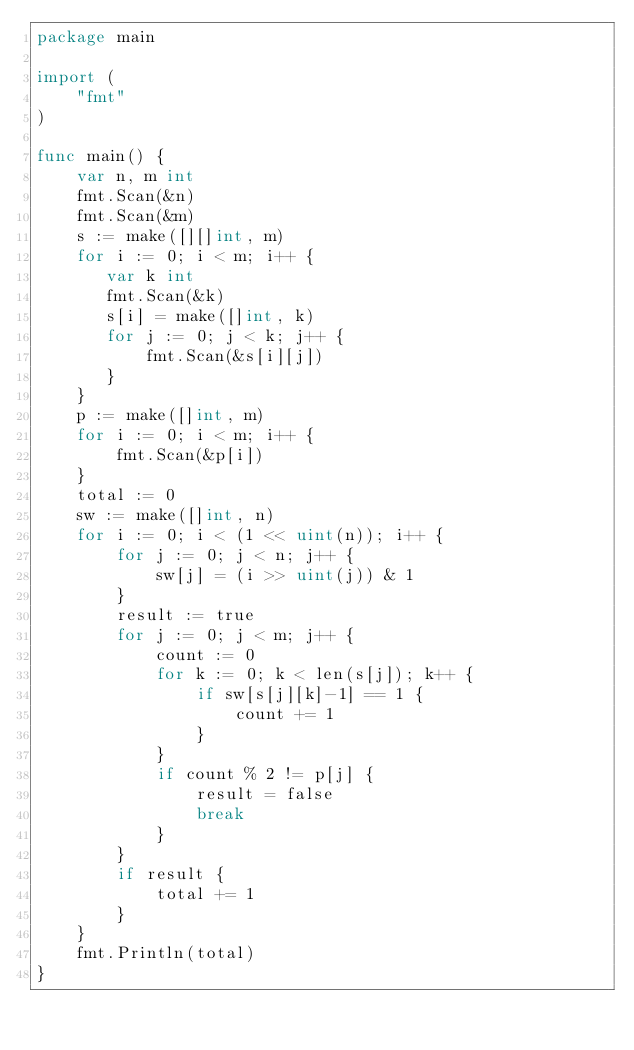Convert code to text. <code><loc_0><loc_0><loc_500><loc_500><_Go_>package main

import (
    "fmt"
)

func main() {
    var n, m int
    fmt.Scan(&n)
    fmt.Scan(&m)
    s := make([][]int, m)
    for i := 0; i < m; i++ {
       var k int
       fmt.Scan(&k)
       s[i] = make([]int, k)
       for j := 0; j < k; j++ {
           fmt.Scan(&s[i][j])
       }
    }
    p := make([]int, m)
    for i := 0; i < m; i++ {
        fmt.Scan(&p[i])
    }
    total := 0
    sw := make([]int, n)
    for i := 0; i < (1 << uint(n)); i++ {
        for j := 0; j < n; j++ {
            sw[j] = (i >> uint(j)) & 1
        }
        result := true
        for j := 0; j < m; j++ {
            count := 0
            for k := 0; k < len(s[j]); k++ {
                if sw[s[j][k]-1] == 1 {
                    count += 1
                }
            }
            if count % 2 != p[j] {
                result = false
                break
            }
        }
        if result {
            total += 1
        }
    }
    fmt.Println(total)
}
</code> 